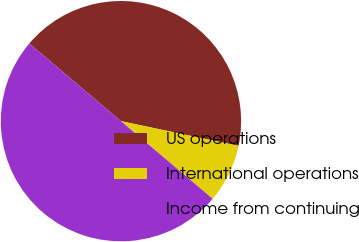Convert chart to OTSL. <chart><loc_0><loc_0><loc_500><loc_500><pie_chart><fcel>US operations<fcel>International operations<fcel>Income from continuing<nl><fcel>42.12%<fcel>7.88%<fcel>50.0%<nl></chart> 